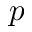<formula> <loc_0><loc_0><loc_500><loc_500>p</formula> 